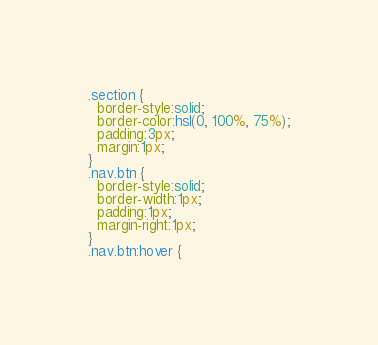Convert code to text. <code><loc_0><loc_0><loc_500><loc_500><_CSS_>.section {
  border-style:solid;
  border-color:hsl(0, 100%, 75%);
  padding:3px;
  margin:1px;
}
.nav.btn {
  border-style:solid;
  border-width:1px;
  padding:1px;
  margin-right:1px;
}
.nav.btn:hover {</code> 